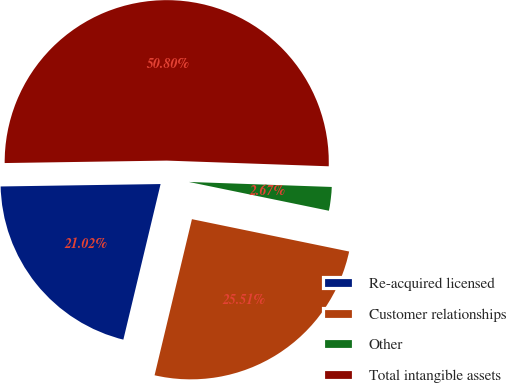<chart> <loc_0><loc_0><loc_500><loc_500><pie_chart><fcel>Re-acquired licensed<fcel>Customer relationships<fcel>Other<fcel>Total intangible assets<nl><fcel>21.02%<fcel>25.51%<fcel>2.67%<fcel>50.8%<nl></chart> 